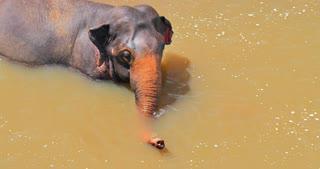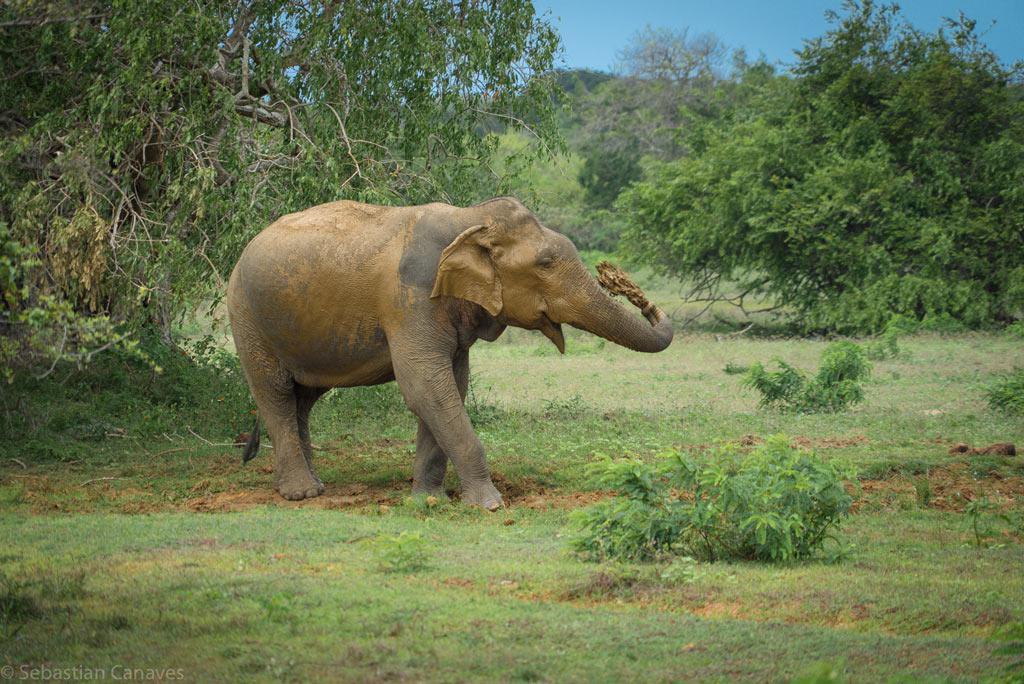The first image is the image on the left, the second image is the image on the right. For the images shown, is this caption "At least one elephant is in the foreground of an image standing in water." true? Answer yes or no. Yes. The first image is the image on the left, the second image is the image on the right. Given the left and right images, does the statement "At least one elephant is standing in water." hold true? Answer yes or no. Yes. 